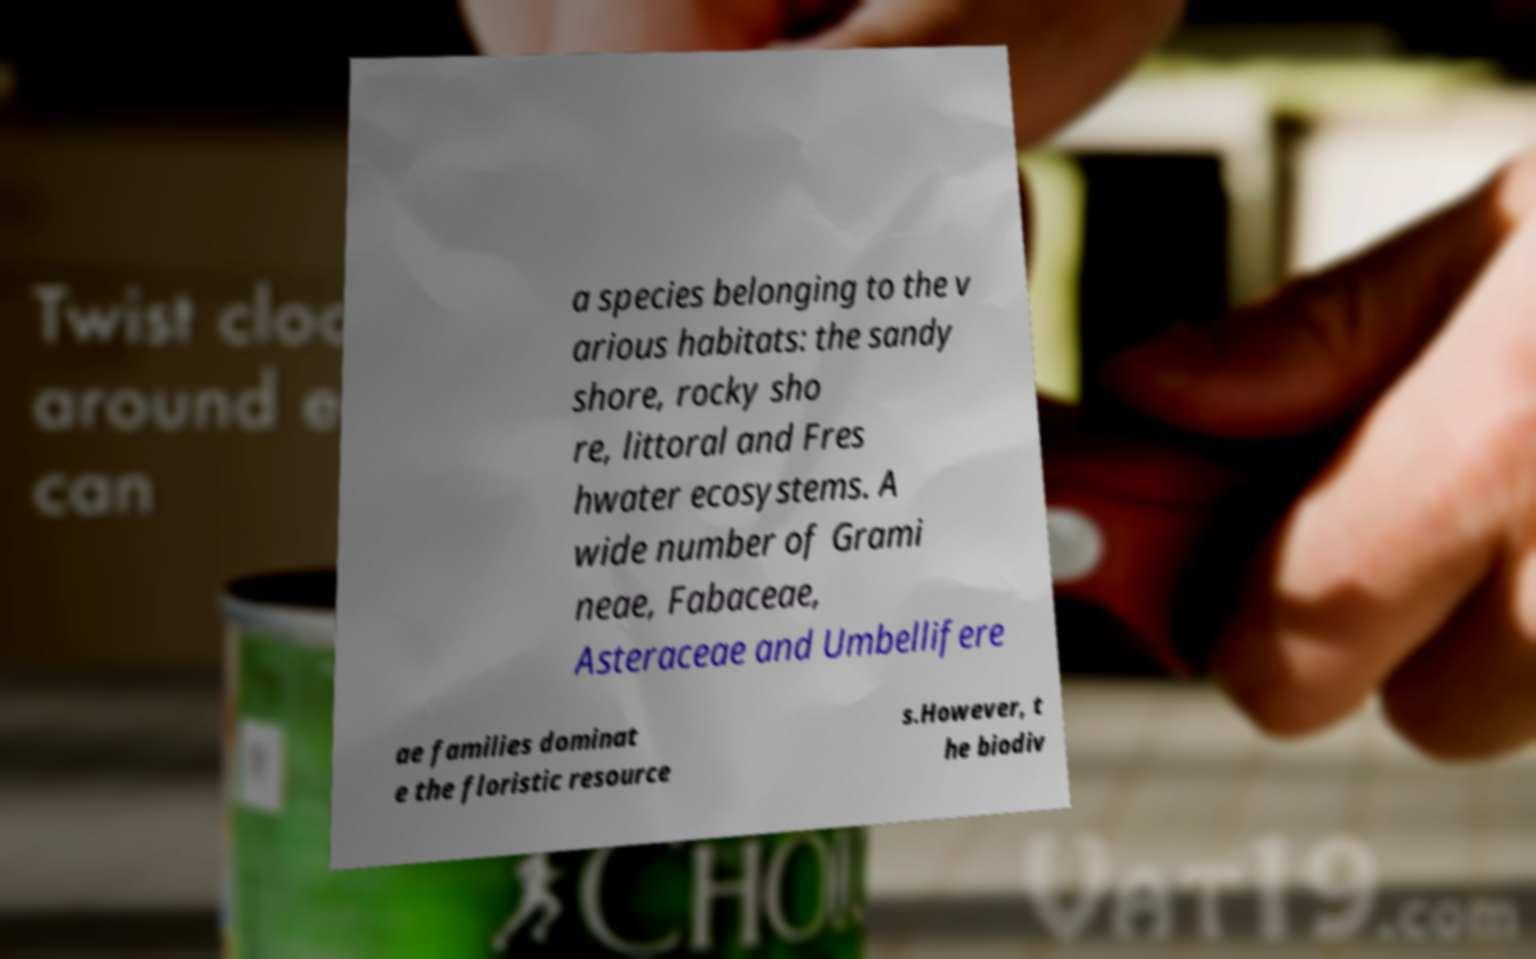Please identify and transcribe the text found in this image. a species belonging to the v arious habitats: the sandy shore, rocky sho re, littoral and Fres hwater ecosystems. A wide number of Grami neae, Fabaceae, Asteraceae and Umbellifere ae families dominat e the floristic resource s.However, t he biodiv 